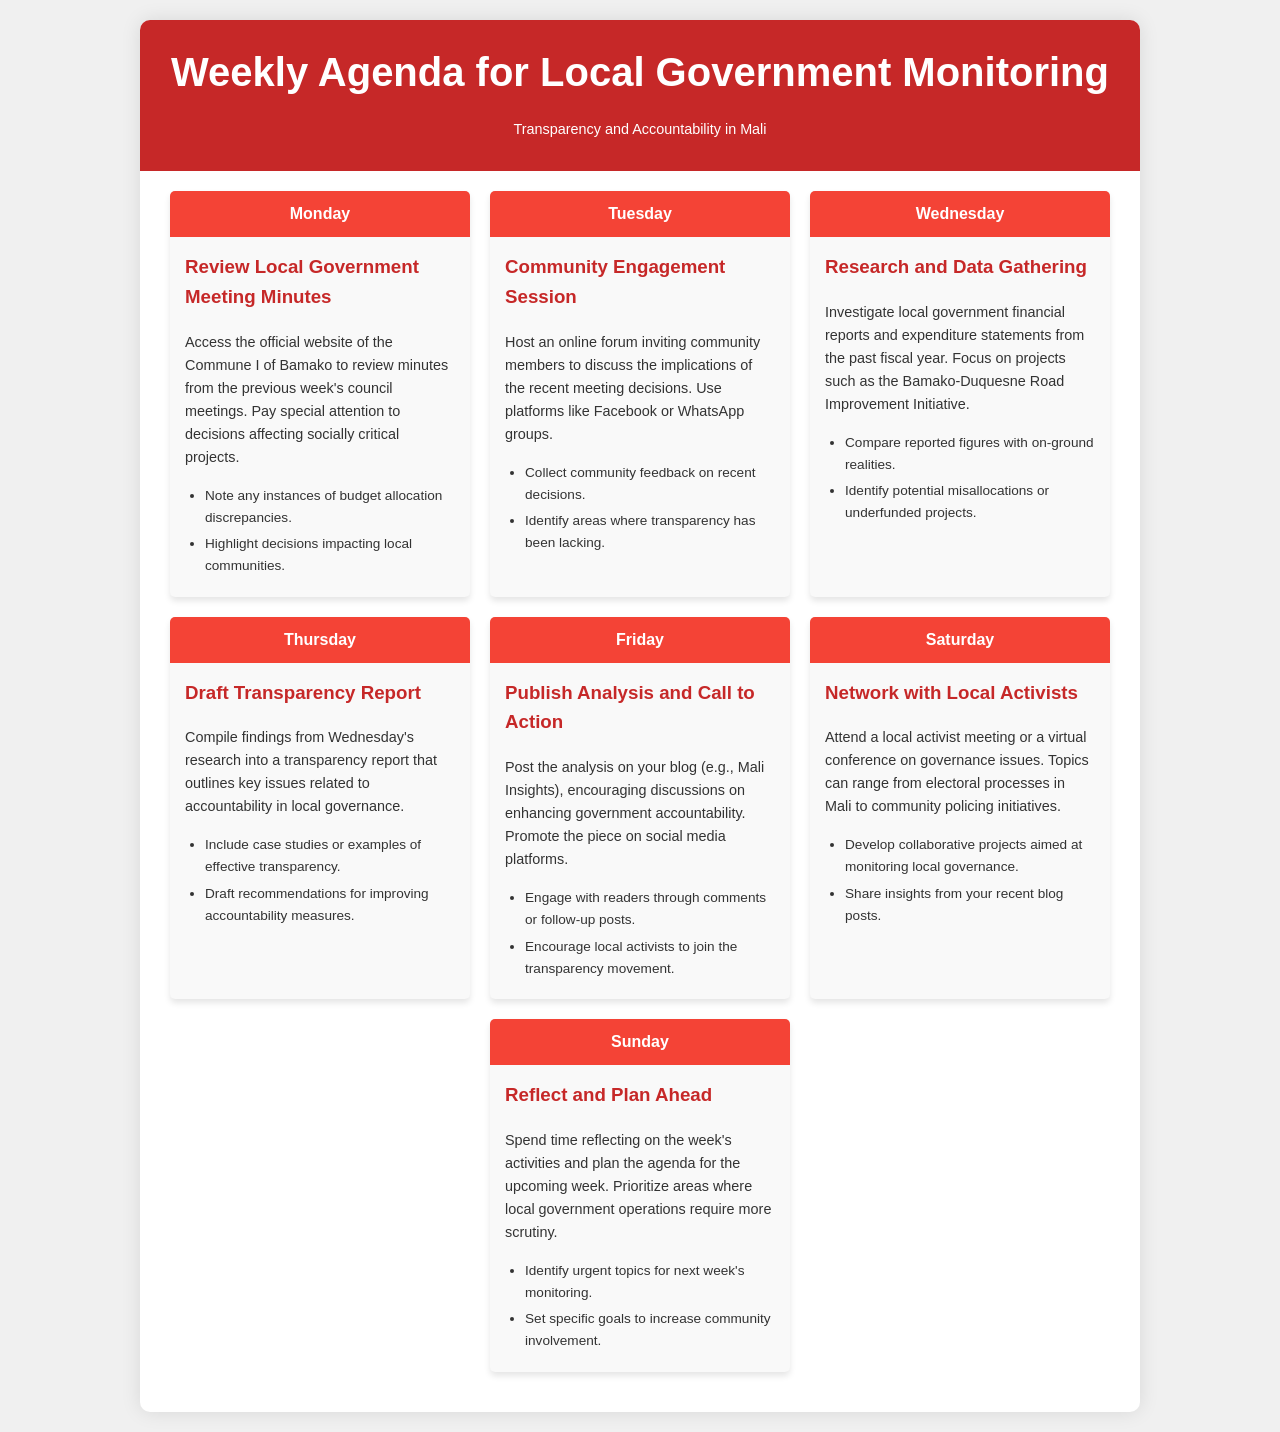What activities are planned for Monday? The agenda for Monday includes reviewing local government meeting minutes from the Commune I of Bamako.
Answer: Review Local Government Meeting Minutes What is emphasized in the Weekly Agenda? The agenda emphasizes transparency and accountability in Mali's local governance.
Answer: Transparency and Accountability Which platform is suggested for community engagement sessions? The document suggests using platforms like Facebook or WhatsApp for community engagement.
Answer: Facebook or WhatsApp What is the focus of the research on Wednesday? Research on Wednesday focuses on local government financial reports and expenditure statements from the past fiscal year.
Answer: Financial reports and expenditure statements What is the final task of the week? The final task of the week involves reflecting on the week's activities and planning for the upcoming week.
Answer: Reflect and Plan Ahead 